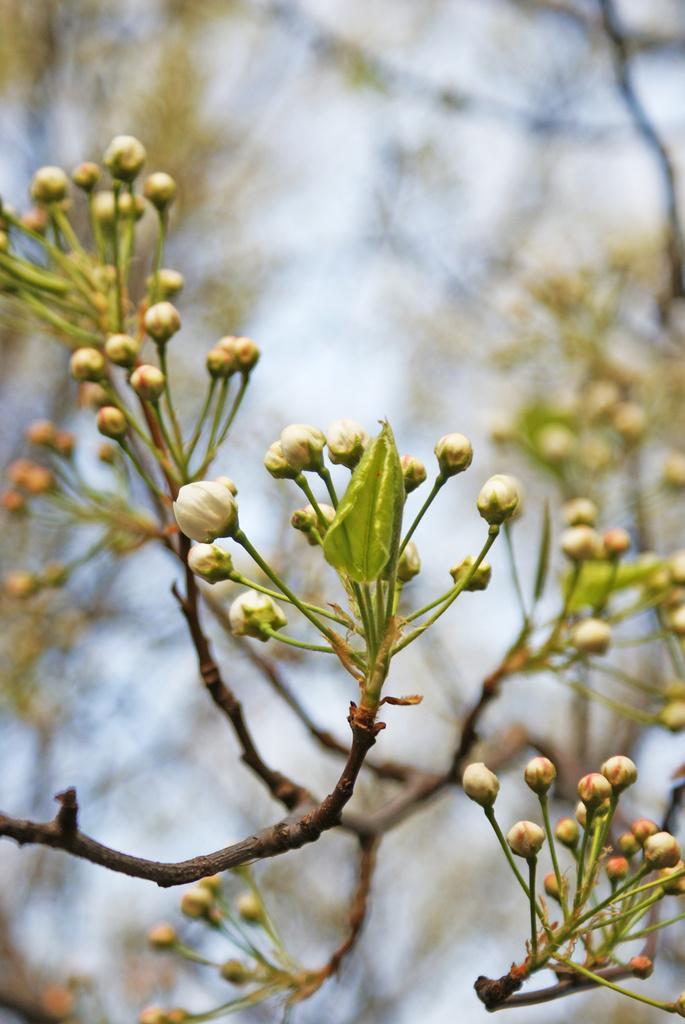Could you give a brief overview of what you see in this image? To the front of the image there are buds and leaves to the stems. And in the background there are green leaves with the stems. 